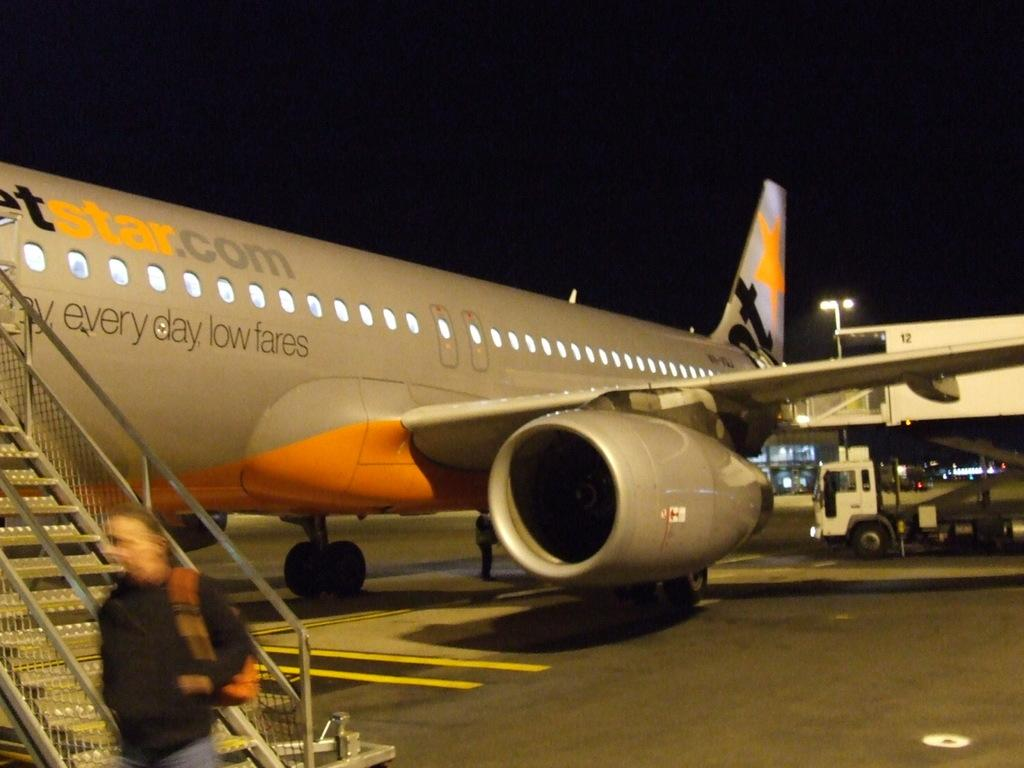<image>
Summarize the visual content of the image. Jetstar.com emblazons it's planes with "everyday low fares". 